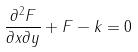<formula> <loc_0><loc_0><loc_500><loc_500>\frac { \partial ^ { 2 } F } { \partial x \partial y } + F - k = 0</formula> 